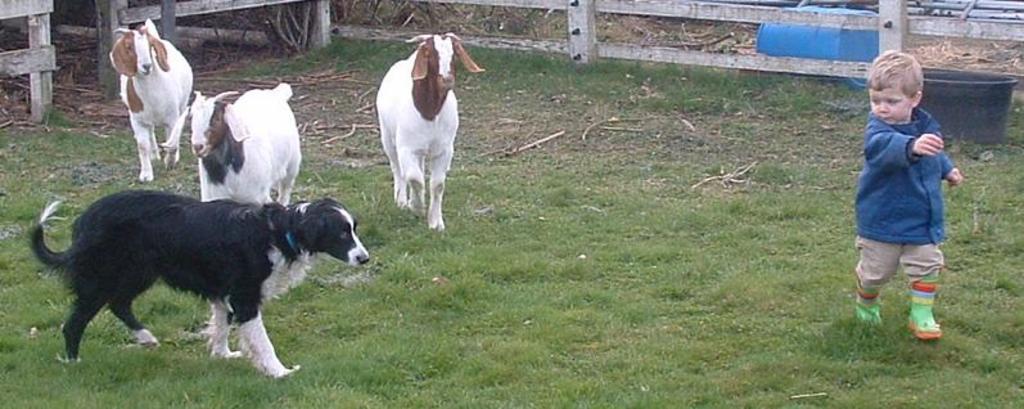Could you give a brief overview of what you see in this image? In this image we can see a boy and a basket on the right side. On the ground there is grass. Also there is a dog and goats. And there are wooden fencing. In the back there is a barrel. 